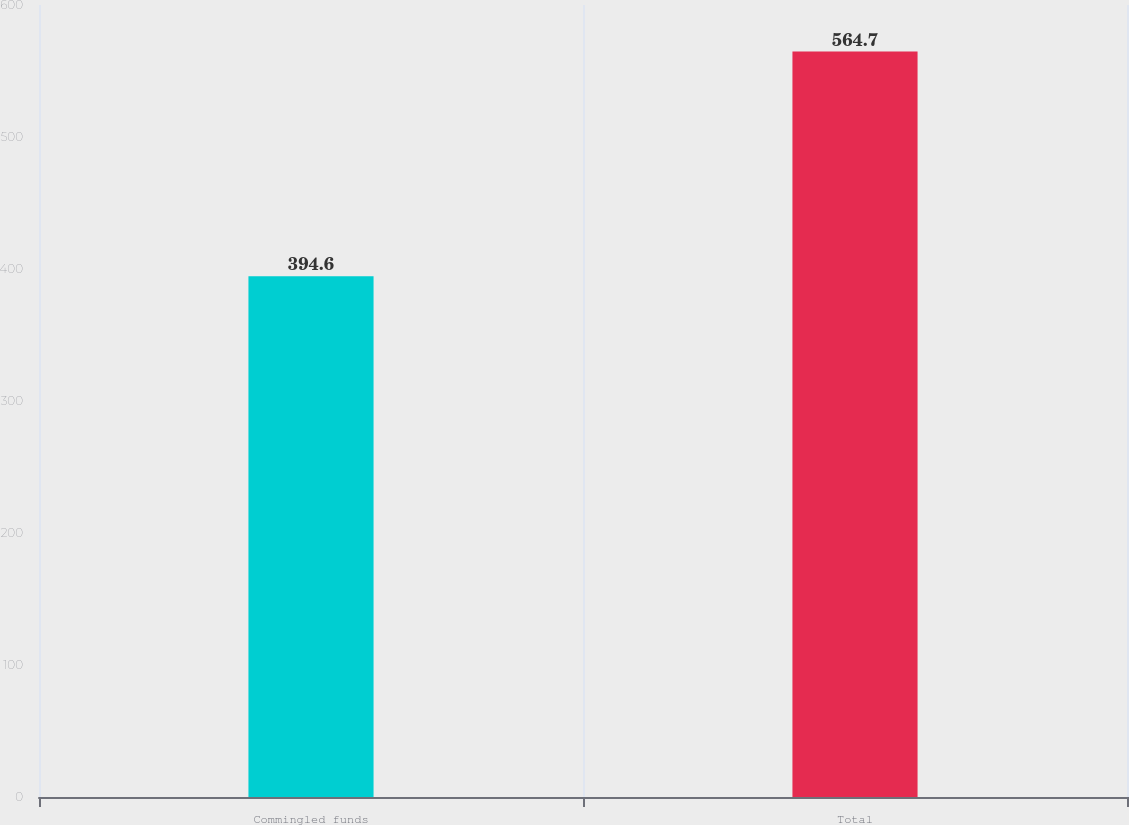<chart> <loc_0><loc_0><loc_500><loc_500><bar_chart><fcel>Commingled funds<fcel>Total<nl><fcel>394.6<fcel>564.7<nl></chart> 